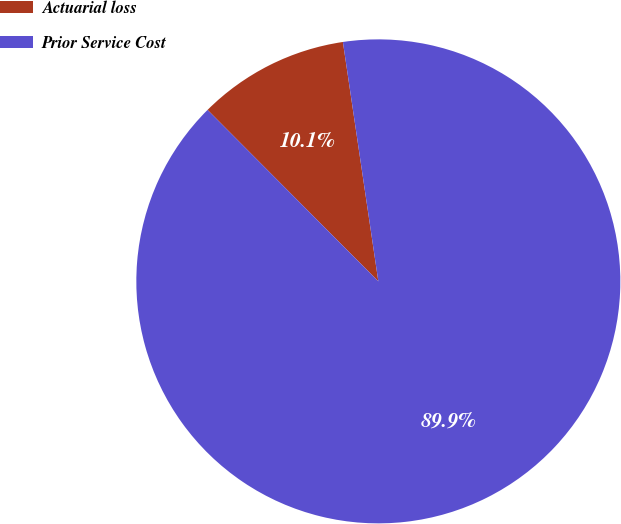<chart> <loc_0><loc_0><loc_500><loc_500><pie_chart><fcel>Actuarial loss<fcel>Prior Service Cost<nl><fcel>10.13%<fcel>89.87%<nl></chart> 